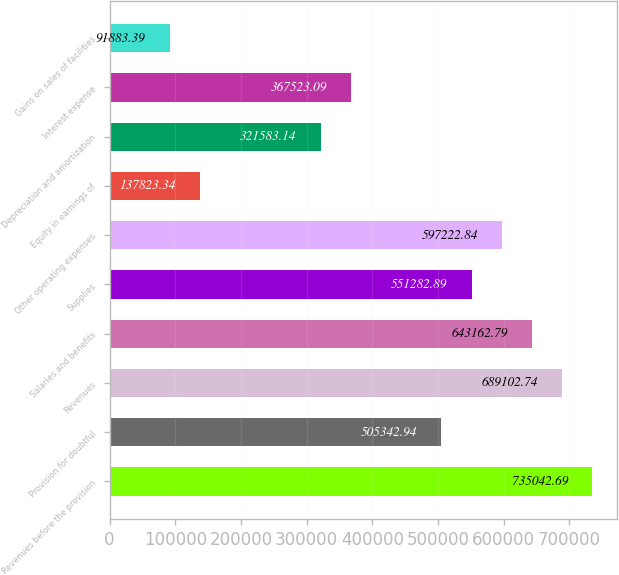<chart> <loc_0><loc_0><loc_500><loc_500><bar_chart><fcel>Revenues before the provision<fcel>Provision for doubtful<fcel>Revenues<fcel>Salaries and benefits<fcel>Supplies<fcel>Other operating expenses<fcel>Equity in earnings of<fcel>Depreciation and amortization<fcel>Interest expense<fcel>Gains on sales of facilities<nl><fcel>735043<fcel>505343<fcel>689103<fcel>643163<fcel>551283<fcel>597223<fcel>137823<fcel>321583<fcel>367523<fcel>91883.4<nl></chart> 